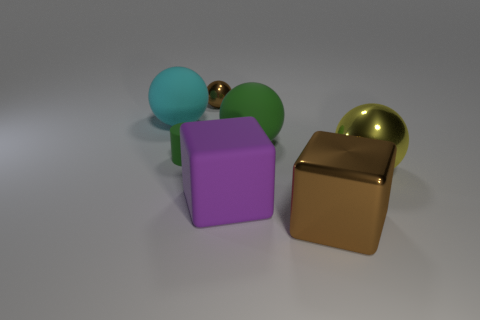What material is the sphere that is the same color as the small cylinder?
Provide a short and direct response. Rubber. There is a metallic sphere that is to the left of the brown thing that is in front of the matte cylinder; what number of big rubber things are in front of it?
Keep it short and to the point. 3. Are there any cyan things made of the same material as the large yellow sphere?
Your response must be concise. No. The cube that is the same color as the small shiny object is what size?
Your answer should be very brief. Large. Are there fewer tiny green rubber blocks than big cyan rubber objects?
Offer a terse response. Yes. Do the shiny object in front of the purple object and the tiny sphere have the same color?
Give a very brief answer. Yes. What is the material of the brown object on the right side of the brown metallic object behind the large matte ball that is left of the small green cylinder?
Offer a terse response. Metal. Are there any large matte spheres that have the same color as the small matte cylinder?
Your answer should be very brief. Yes. Is the number of green cylinders to the right of the large green matte object less than the number of green rubber cylinders?
Your answer should be very brief. Yes. There is a brown shiny thing in front of the brown metal ball; is it the same size as the small rubber cylinder?
Make the answer very short. No. 